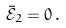<formula> <loc_0><loc_0><loc_500><loc_500>\bar { \mathcal { E } } _ { 2 } = 0 \, .</formula> 